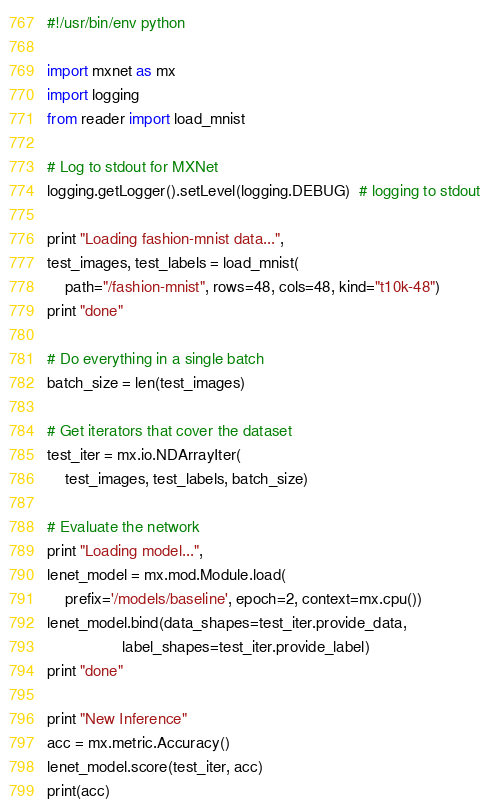<code> <loc_0><loc_0><loc_500><loc_500><_Python_>#!/usr/bin/env python

import mxnet as mx
import logging
from reader import load_mnist

# Log to stdout for MXNet
logging.getLogger().setLevel(logging.DEBUG)  # logging to stdout

print "Loading fashion-mnist data...",
test_images, test_labels = load_mnist(
    path="/fashion-mnist", rows=48, cols=48, kind="t10k-48")
print "done"

# Do everything in a single batch
batch_size = len(test_images)

# Get iterators that cover the dataset
test_iter = mx.io.NDArrayIter(
    test_images, test_labels, batch_size)

# Evaluate the network
print "Loading model...",
lenet_model = mx.mod.Module.load(
    prefix='/models/baseline', epoch=2, context=mx.cpu())
lenet_model.bind(data_shapes=test_iter.provide_data,
                 label_shapes=test_iter.provide_label)
print "done"

print "New Inference"
acc = mx.metric.Accuracy()
lenet_model.score(test_iter, acc)
print(acc)
</code> 